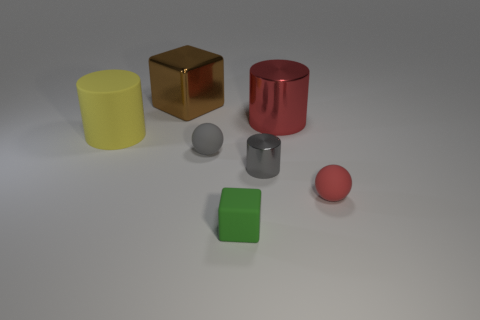Subtract all metal cylinders. How many cylinders are left? 1 Add 1 large things. How many objects exist? 8 Subtract all cubes. How many objects are left? 5 Subtract all gray cylinders. How many cylinders are left? 2 Subtract 1 blocks. How many blocks are left? 1 Subtract 0 green spheres. How many objects are left? 7 Subtract all cyan cylinders. Subtract all gray blocks. How many cylinders are left? 3 Subtract all green balls. How many blue cylinders are left? 0 Subtract all yellow rubber cylinders. Subtract all red rubber things. How many objects are left? 5 Add 5 rubber cubes. How many rubber cubes are left? 6 